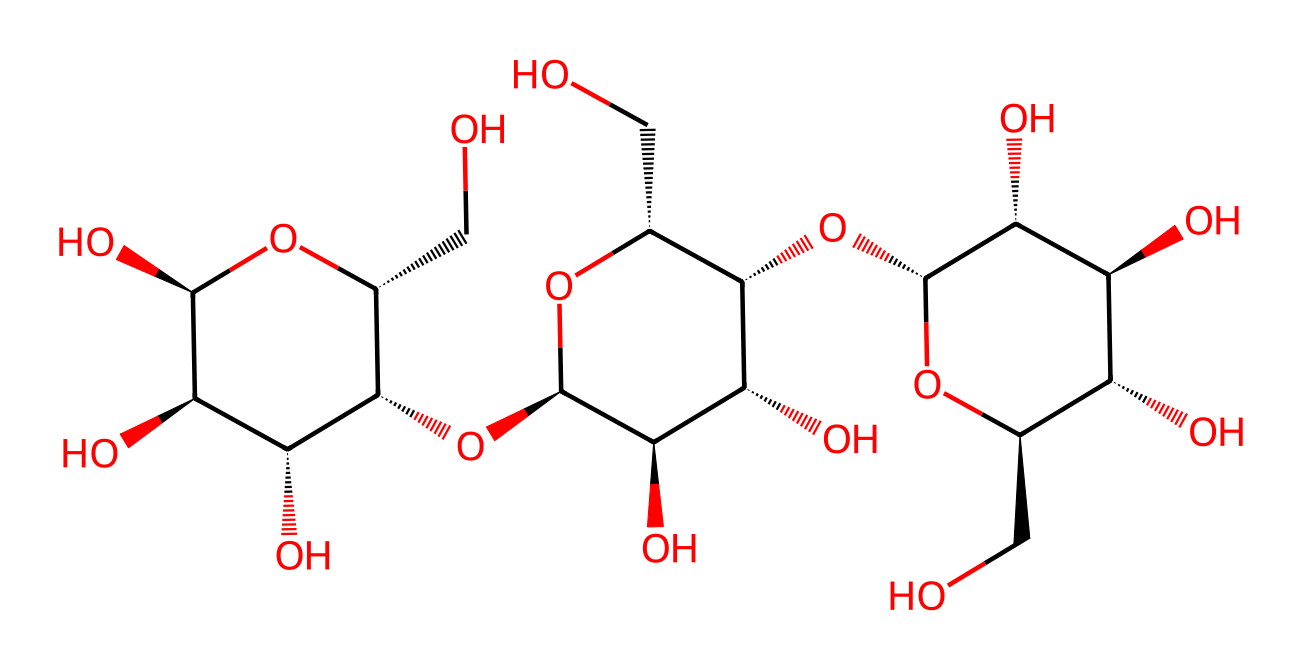What is the primary functional group present in cellulose? The primary functional group in cellulose is the hydroxyl group, as seen in multiple -OH groups attached to the carbon backbone in the structure.
Answer: hydroxyl group How many carbon atoms are in the cellulose structure? By analyzing the SMILES representation and counting the carbon atoms, it is seen that there are 6 carbon atoms in each repeating unit of cellulose, but the total depends on the polymer length. In this instance, the structure reflects a longer chain comprising multiple units, but a direct count from a portion shows at least 6.
Answer: six Which type of polymer is cellulose classified as? Cellulose is a polysaccharide, which is classified as a carbohydrate because it consists of long chains of glucose molecules linked by glycosidic bonds.
Answer: polysaccharide What does the presence of multiple hydroxyl groups indicate about cellulose? The multiple hydroxyl groups in cellulose increase its hydrophilicity, allowing for hydrogen bonding with water and other molecules. This feature is responsible for cellulose's solubility properties and interaction with water.
Answer: hydrophilicity Is cellulose soluble in water? Cellulose is not soluble in water due to its extensive hydrogen bonding between chains, which creates a stable structure that resists dissolution.
Answer: no What type of linkage connects the glucose units in cellulose? In cellulose, the glucose units are connected by beta-1,4-glycosidic linkages, which define the orientation and properties of the polymer chain.
Answer: beta-1,4-glycosidic linkage 